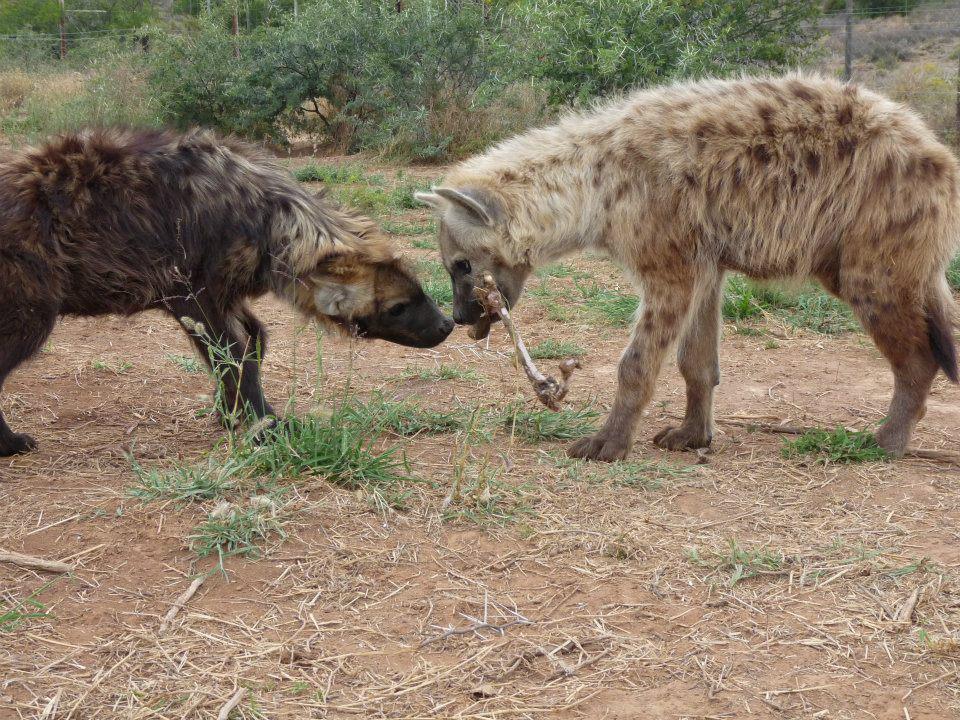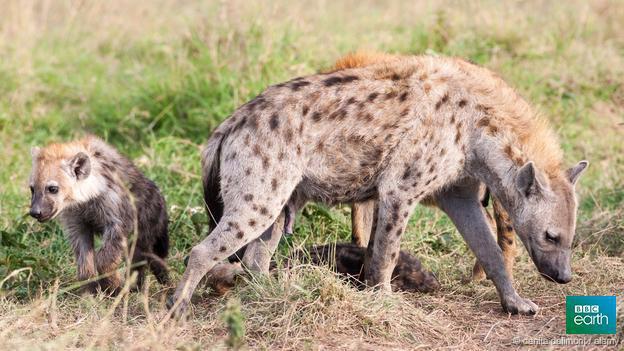The first image is the image on the left, the second image is the image on the right. Assess this claim about the two images: "At least one hyena has its legs in water.". Correct or not? Answer yes or no. No. The first image is the image on the left, the second image is the image on the right. For the images shown, is this caption "A hyena is carrying something in its mouth." true? Answer yes or no. Yes. 